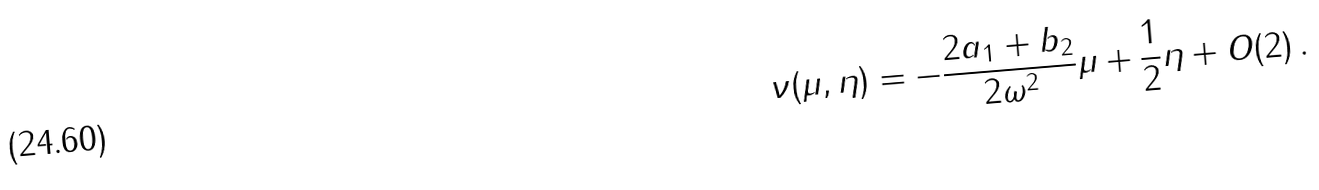<formula> <loc_0><loc_0><loc_500><loc_500>\nu ( \mu , \eta ) = - \frac { 2 a _ { 1 } + b _ { 2 } } { 2 \omega ^ { 2 } } \mu + \frac { 1 } { 2 } \eta + O ( 2 ) \, .</formula> 